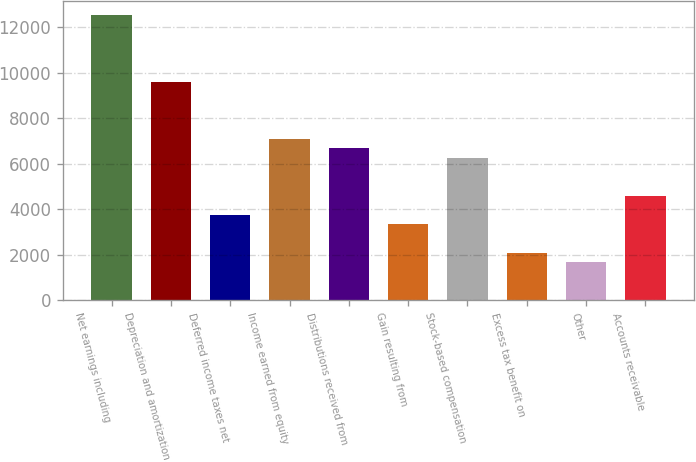Convert chart to OTSL. <chart><loc_0><loc_0><loc_500><loc_500><bar_chart><fcel>Net earnings including<fcel>Depreciation and amortization<fcel>Deferred income taxes net<fcel>Income earned from equity<fcel>Distributions received from<fcel>Gain resulting from<fcel>Stock-based compensation<fcel>Excess tax benefit on<fcel>Other<fcel>Accounts receivable<nl><fcel>12513.5<fcel>9594.78<fcel>3757.34<fcel>7093.02<fcel>6676.06<fcel>3340.38<fcel>6259.1<fcel>2089.5<fcel>1672.54<fcel>4591.26<nl></chart> 